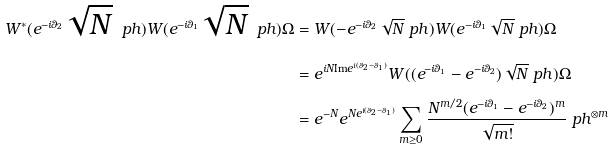<formula> <loc_0><loc_0><loc_500><loc_500>W ^ { * } ( e ^ { - i \theta _ { 2 } } \sqrt { N } \ p h ) W ( e ^ { - i \theta _ { 1 } } \sqrt { N } \ p h ) \Omega & = W ( - e ^ { - i \theta _ { 2 } } \sqrt { N } \ p h ) W ( e ^ { - i \theta _ { 1 } } \sqrt { N } \ p h ) \Omega \\ & = e ^ { i N \text {Im} e ^ { i ( \theta _ { 2 } - \theta _ { 1 } ) } } W ( ( e ^ { - i \theta _ { 1 } } - e ^ { - i \theta _ { 2 } } ) \sqrt { N } \ p h ) \Omega \\ & = e ^ { - N } e ^ { N e ^ { i ( \theta _ { 2 } - \theta _ { 1 } ) } } \sum _ { m \geq 0 } \frac { N ^ { m / 2 } ( e ^ { - i \theta _ { 1 } } - e ^ { - i \theta _ { 2 } } ) ^ { m } } { \sqrt { m ! } } \ p h ^ { \otimes m }</formula> 